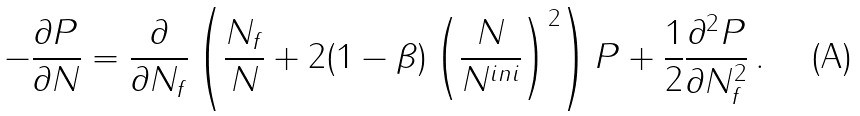Convert formula to latex. <formula><loc_0><loc_0><loc_500><loc_500>- \frac { \partial P } { \partial N } = \frac { \partial } { \partial N _ { f } } \left ( \frac { N _ { f } } { N } + 2 ( 1 - \beta ) \left ( \frac { N } { N ^ { i n i } } \right ) ^ { 2 } \right ) P + \frac { 1 } { 2 } \frac { \partial ^ { 2 } P } { \partial N _ { f } ^ { 2 } } \, .</formula> 